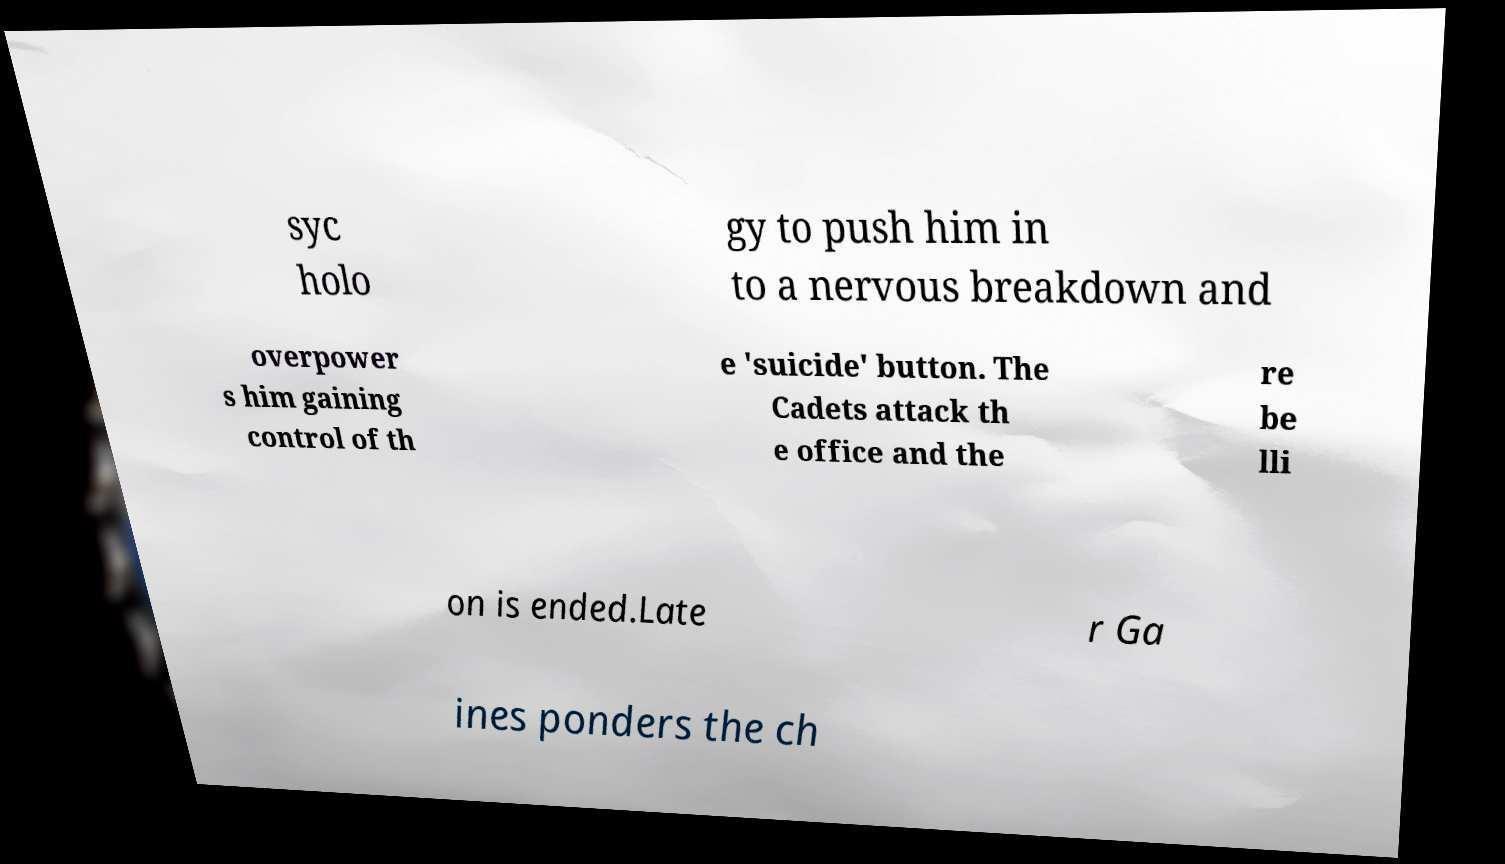Can you read and provide the text displayed in the image?This photo seems to have some interesting text. Can you extract and type it out for me? syc holo gy to push him in to a nervous breakdown and overpower s him gaining control of th e 'suicide' button. The Cadets attack th e office and the re be lli on is ended.Late r Ga ines ponders the ch 